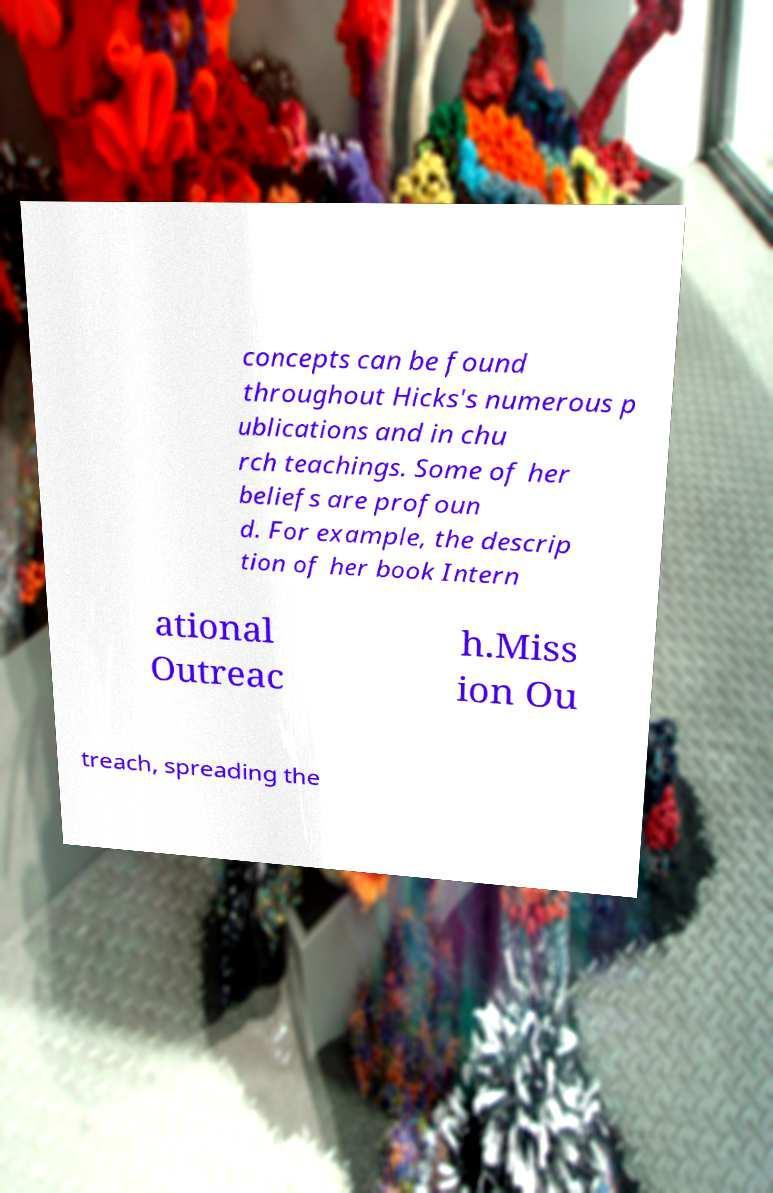What messages or text are displayed in this image? I need them in a readable, typed format. concepts can be found throughout Hicks's numerous p ublications and in chu rch teachings. Some of her beliefs are profoun d. For example, the descrip tion of her book Intern ational Outreac h.Miss ion Ou treach, spreading the 